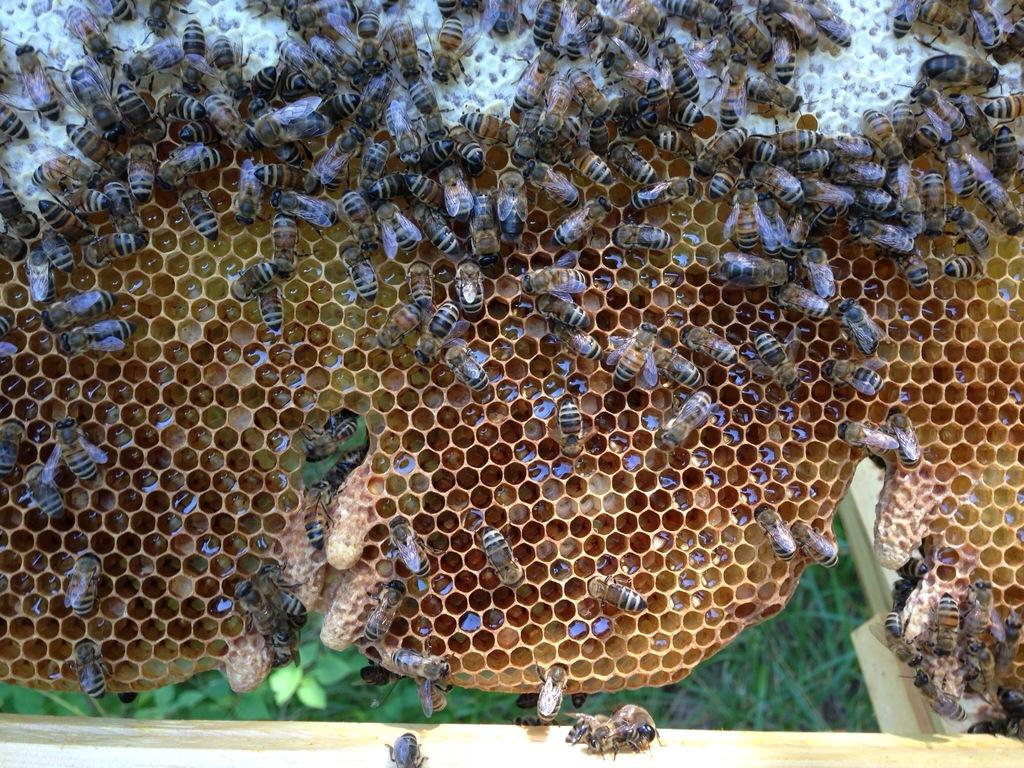What type of insects can be seen in the image? There are honey bees in the image. What structures are associated with the honey bees in the image? There are honey bee hives in the image. What type of vegetation can be seen in the background of the image? There are leaves in the background of the image. What type of stitch is used to create the dress in the image? There is no dress present in the image, so it is not possible to determine the type of stitch used. 